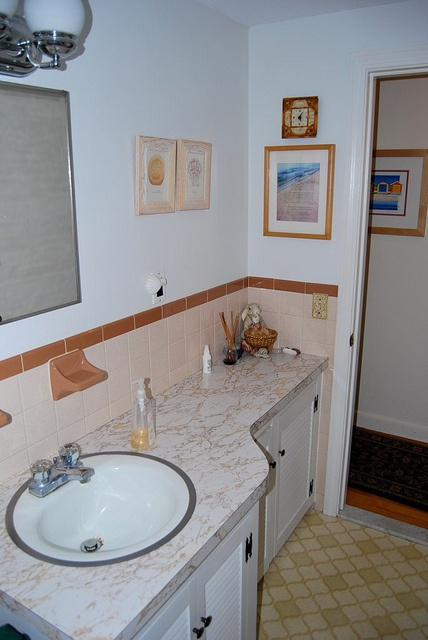Describe the objects in this image and their specific colors. I can see sink in darkgray and lightgray tones and bottle in darkgray, tan, gray, and lightgray tones in this image. 